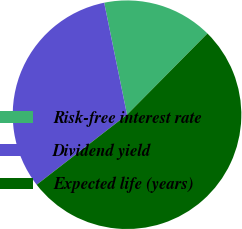<chart> <loc_0><loc_0><loc_500><loc_500><pie_chart><fcel>Risk-free interest rate<fcel>Dividend yield<fcel>Expected life (years)<nl><fcel>15.62%<fcel>32.29%<fcel>52.08%<nl></chart> 